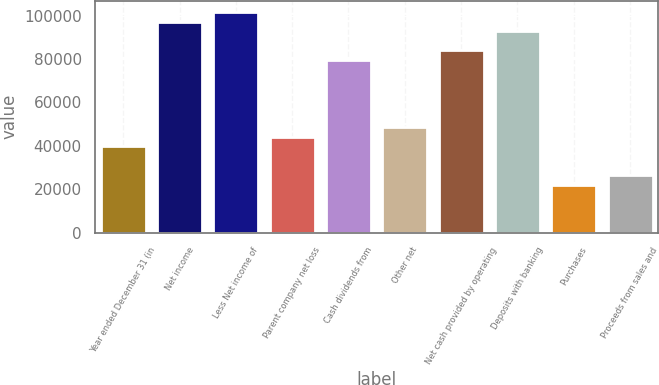Convert chart. <chart><loc_0><loc_0><loc_500><loc_500><bar_chart><fcel>Year ended December 31 (in<fcel>Net income<fcel>Less Net income of<fcel>Parent company net loss<fcel>Cash dividends from<fcel>Other net<fcel>Net cash provided by operating<fcel>Deposits with banking<fcel>Purchases<fcel>Proceeds from sales and<nl><fcel>39824.4<fcel>97227.2<fcel>101643<fcel>44240<fcel>79564.8<fcel>48655.6<fcel>83980.4<fcel>92811.6<fcel>22162<fcel>26577.6<nl></chart> 